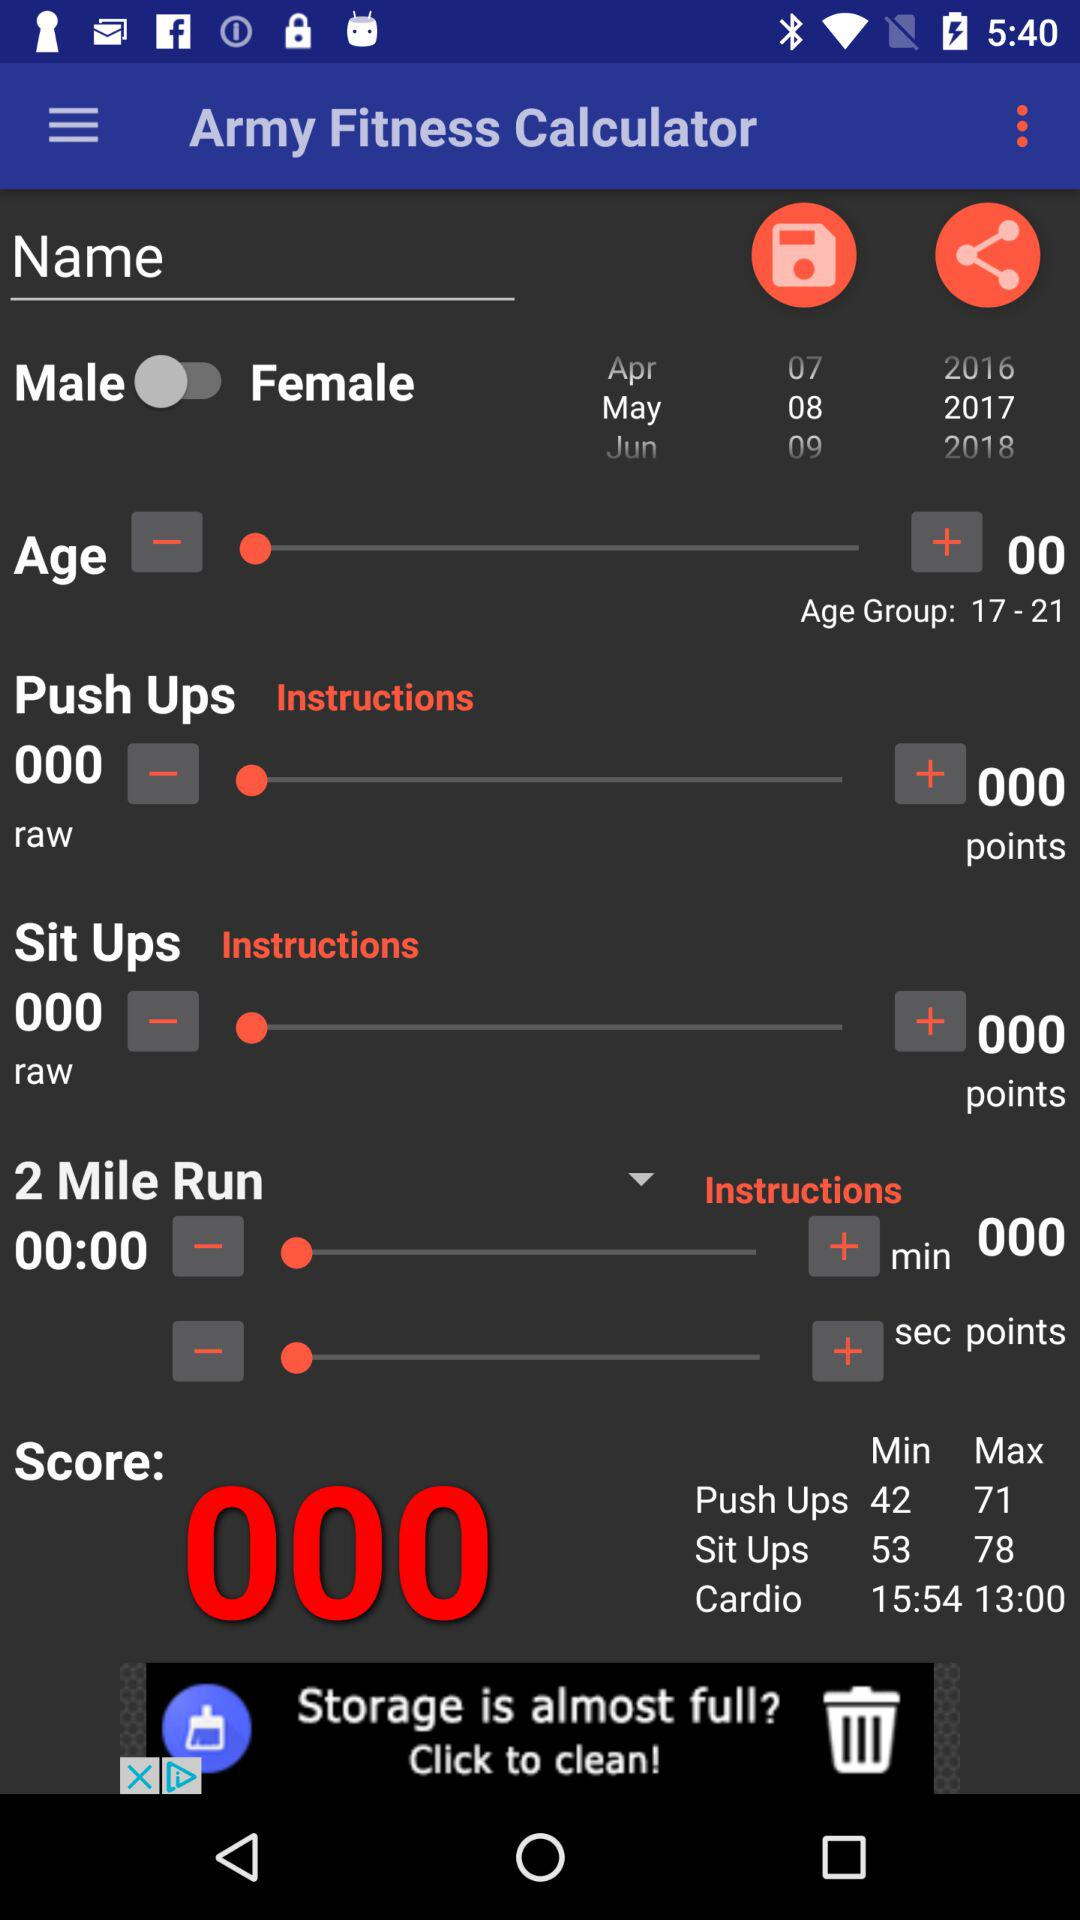What is the maximum sit-up score? The maximum sit-up score is 78. 